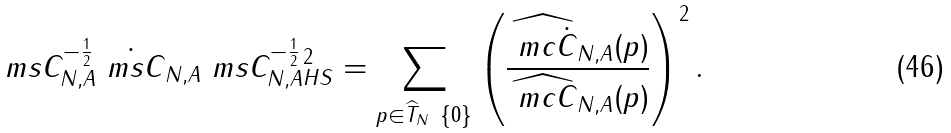<formula> <loc_0><loc_0><loc_500><loc_500>\| \ m s { C } _ { N , A } ^ { - \frac { 1 } { 2 } } \dot { \ m s { C } } _ { N , A } \ m s { C } _ { N , A } ^ { - \frac { 1 } { 2 } } \| _ { H S } ^ { 2 } = \sum _ { p \in \widehat { T } _ { N } \ \{ 0 \} } \left ( \frac { \widehat { \ m c { \dot { C } } } _ { N , A } ( p ) } { \widehat { \ m c { C } } _ { N , A } ( p ) } \right ) ^ { 2 } .</formula> 